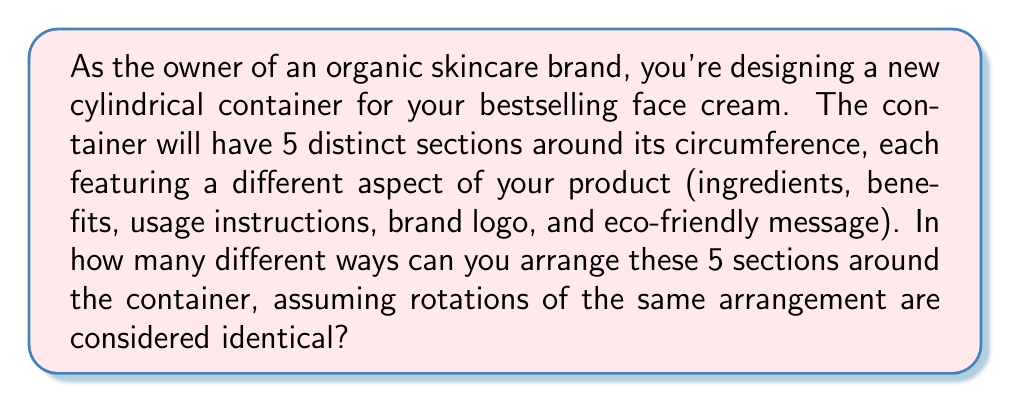Teach me how to tackle this problem. Let's approach this step-by-step:

1) First, we need to recognize that this is a circular permutation problem. In a circular arrangement, rotations of the same arrangement are considered identical.

2) For linear arrangements, we would have 5! (5 factorial) ways to arrange 5 distinct objects. However, for circular arrangements, we need to divide this by the number of rotations possible.

3) The formula for circular permutations of n distinct objects is:

   $$(n-1)!$$

4) In this case, n = 5 (ingredients, benefits, usage instructions, brand logo, and eco-friendly message)

5) Therefore, the number of unique arrangements is:

   $$(5-1)! = 4! = 4 \times 3 \times 2 \times 1 = 24$$

6) We can visualize this as follows:

   [asy]
   unitsize(2cm);
   for(int i=0; i<5; ++i) {
     draw(circle((0,0),1));
     for(int j=0; j<5; ++j) {
       draw((0,0)--dir(72*j));
     }
     label("A", dir(0));
     label("B", dir(72));
     label("C", dir(144));
     label("D", dir(216));
     label("E", dir(288));
   }
   [/asy]

   Here, A, B, C, D, and E represent the five sections. Any rotation of this arrangement (e.g., BCDEA, CDEAB) is considered the same arrangement.

Thus, there are 24 unique ways to arrange the 5 sections around your cylindrical container.
Answer: 24 ways 